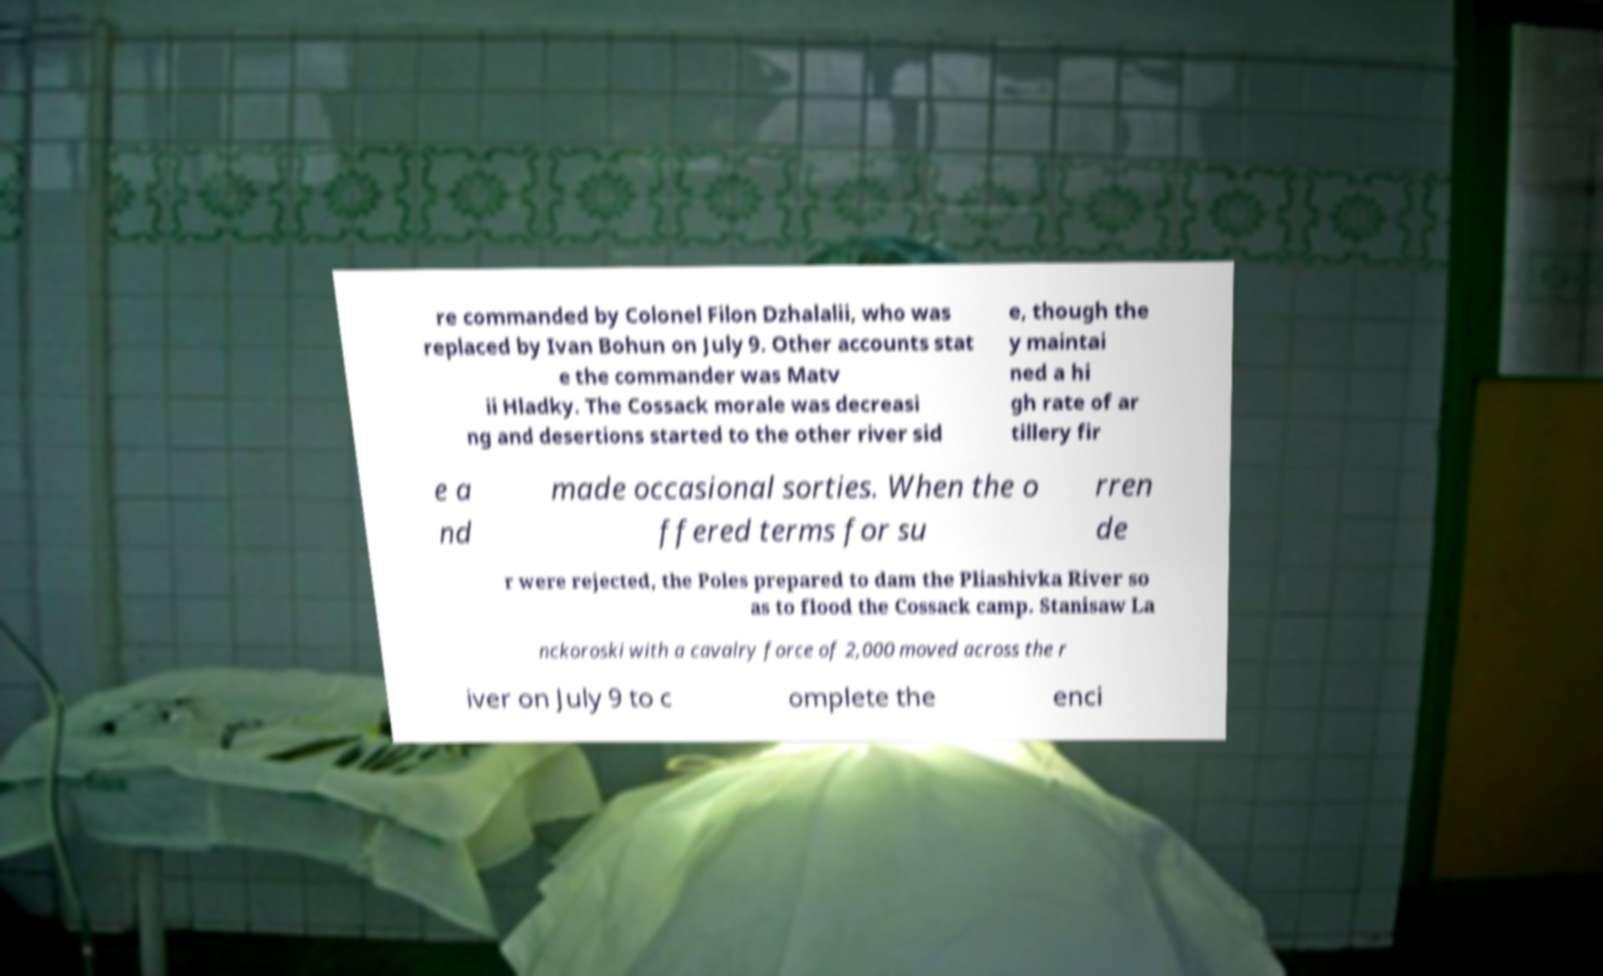Could you extract and type out the text from this image? re commanded by Colonel Filon Dzhalalii, who was replaced by Ivan Bohun on July 9. Other accounts stat e the commander was Matv ii Hladky. The Cossack morale was decreasi ng and desertions started to the other river sid e, though the y maintai ned a hi gh rate of ar tillery fir e a nd made occasional sorties. When the o ffered terms for su rren de r were rejected, the Poles prepared to dam the Pliashivka River so as to flood the Cossack camp. Stanisaw La nckoroski with a cavalry force of 2,000 moved across the r iver on July 9 to c omplete the enci 